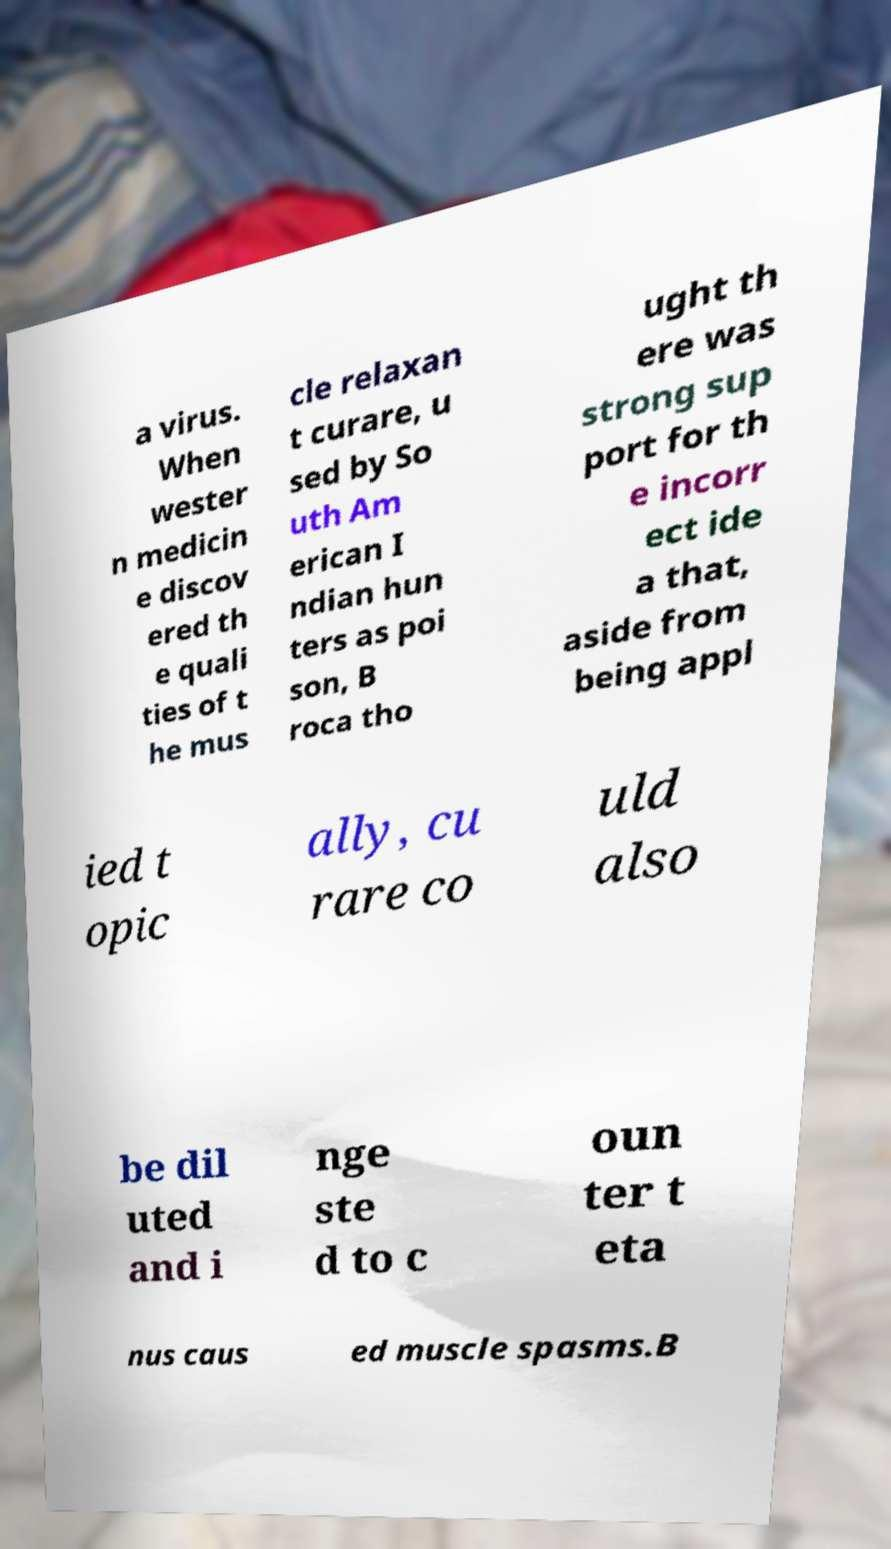Could you assist in decoding the text presented in this image and type it out clearly? a virus. When wester n medicin e discov ered th e quali ties of t he mus cle relaxan t curare, u sed by So uth Am erican I ndian hun ters as poi son, B roca tho ught th ere was strong sup port for th e incorr ect ide a that, aside from being appl ied t opic ally, cu rare co uld also be dil uted and i nge ste d to c oun ter t eta nus caus ed muscle spasms.B 